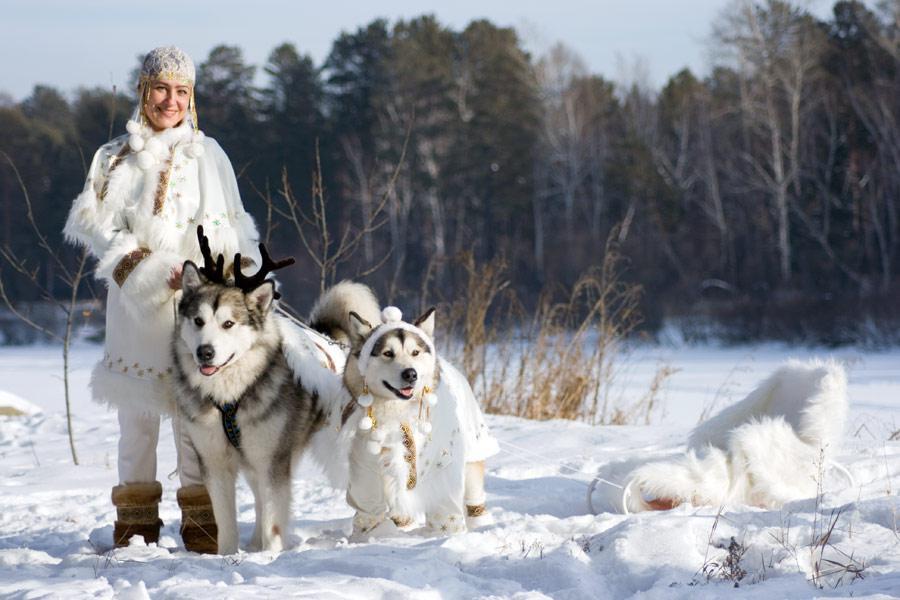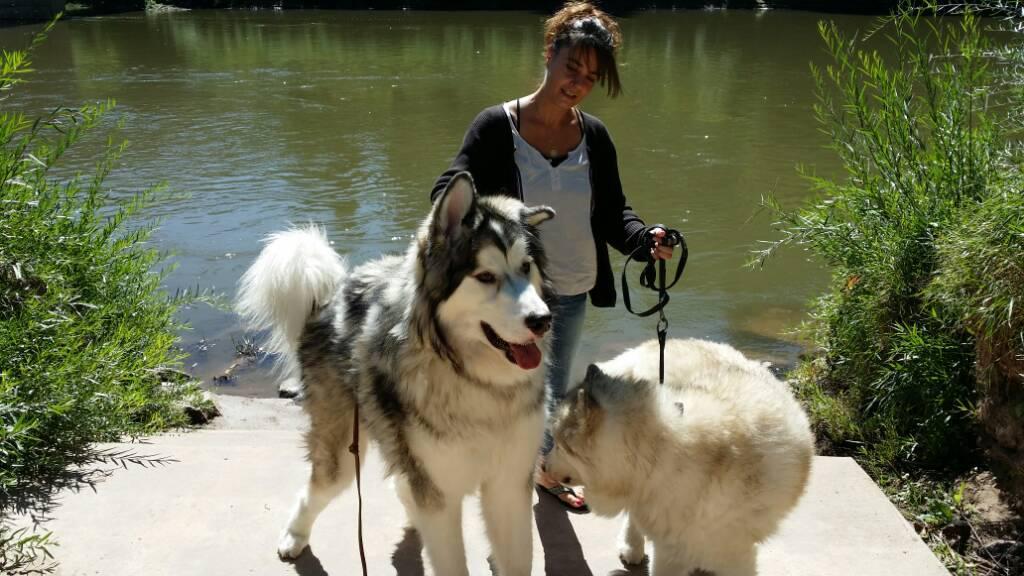The first image is the image on the left, the second image is the image on the right. For the images displayed, is the sentence "The left image includes two huskies side-by-side on snowy ground, and the right image includes one woman with at least one husky." factually correct? Answer yes or no. Yes. 